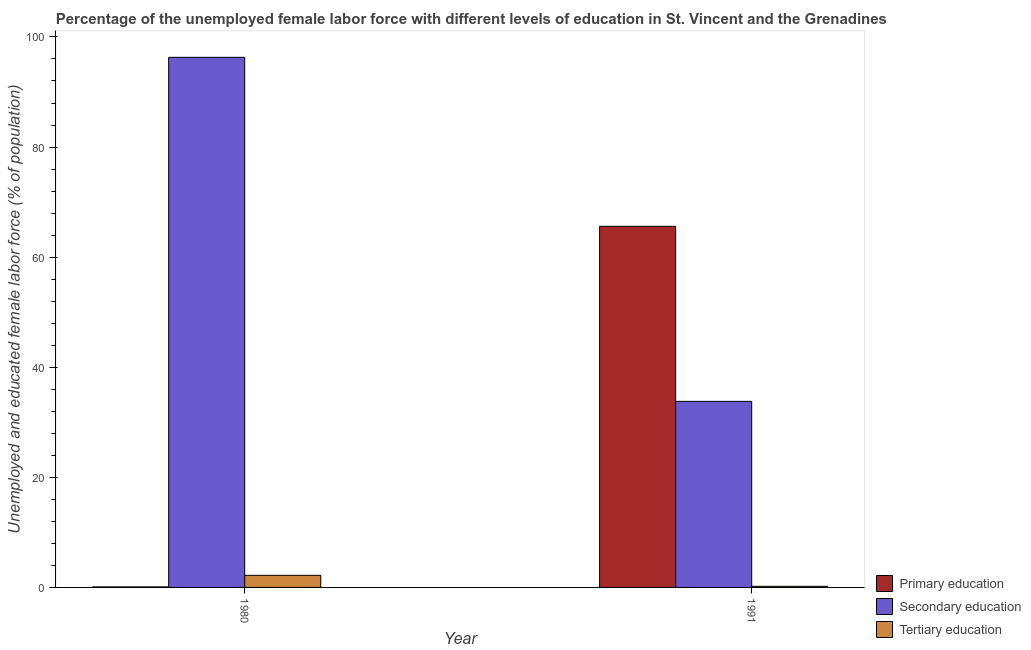How many different coloured bars are there?
Offer a terse response. 3. How many groups of bars are there?
Ensure brevity in your answer.  2. Are the number of bars per tick equal to the number of legend labels?
Your answer should be compact. Yes. Are the number of bars on each tick of the X-axis equal?
Offer a terse response. Yes. How many bars are there on the 1st tick from the right?
Make the answer very short. 3. What is the label of the 2nd group of bars from the left?
Your response must be concise. 1991. In how many cases, is the number of bars for a given year not equal to the number of legend labels?
Provide a succinct answer. 0. What is the percentage of female labor force who received primary education in 1980?
Make the answer very short. 0.1. Across all years, what is the maximum percentage of female labor force who received primary education?
Provide a short and direct response. 65.6. Across all years, what is the minimum percentage of female labor force who received secondary education?
Ensure brevity in your answer.  33.8. What is the total percentage of female labor force who received secondary education in the graph?
Offer a terse response. 130.1. What is the difference between the percentage of female labor force who received primary education in 1980 and that in 1991?
Ensure brevity in your answer.  -65.5. What is the difference between the percentage of female labor force who received primary education in 1980 and the percentage of female labor force who received secondary education in 1991?
Make the answer very short. -65.5. What is the average percentage of female labor force who received tertiary education per year?
Your answer should be compact. 1.2. In how many years, is the percentage of female labor force who received primary education greater than 40 %?
Provide a short and direct response. 1. What is the ratio of the percentage of female labor force who received tertiary education in 1980 to that in 1991?
Give a very brief answer. 11. In how many years, is the percentage of female labor force who received primary education greater than the average percentage of female labor force who received primary education taken over all years?
Keep it short and to the point. 1. What does the 2nd bar from the right in 1980 represents?
Make the answer very short. Secondary education. How many bars are there?
Keep it short and to the point. 6. Are all the bars in the graph horizontal?
Offer a terse response. No. How many years are there in the graph?
Provide a succinct answer. 2. What is the difference between two consecutive major ticks on the Y-axis?
Offer a very short reply. 20. Does the graph contain grids?
Offer a terse response. No. How many legend labels are there?
Give a very brief answer. 3. What is the title of the graph?
Offer a very short reply. Percentage of the unemployed female labor force with different levels of education in St. Vincent and the Grenadines. What is the label or title of the Y-axis?
Provide a short and direct response. Unemployed and educated female labor force (% of population). What is the Unemployed and educated female labor force (% of population) of Primary education in 1980?
Your answer should be compact. 0.1. What is the Unemployed and educated female labor force (% of population) in Secondary education in 1980?
Ensure brevity in your answer.  96.3. What is the Unemployed and educated female labor force (% of population) in Tertiary education in 1980?
Offer a terse response. 2.2. What is the Unemployed and educated female labor force (% of population) of Primary education in 1991?
Provide a succinct answer. 65.6. What is the Unemployed and educated female labor force (% of population) of Secondary education in 1991?
Ensure brevity in your answer.  33.8. What is the Unemployed and educated female labor force (% of population) of Tertiary education in 1991?
Give a very brief answer. 0.2. Across all years, what is the maximum Unemployed and educated female labor force (% of population) in Primary education?
Your answer should be compact. 65.6. Across all years, what is the maximum Unemployed and educated female labor force (% of population) in Secondary education?
Keep it short and to the point. 96.3. Across all years, what is the maximum Unemployed and educated female labor force (% of population) in Tertiary education?
Keep it short and to the point. 2.2. Across all years, what is the minimum Unemployed and educated female labor force (% of population) in Primary education?
Provide a succinct answer. 0.1. Across all years, what is the minimum Unemployed and educated female labor force (% of population) in Secondary education?
Your answer should be compact. 33.8. Across all years, what is the minimum Unemployed and educated female labor force (% of population) in Tertiary education?
Offer a very short reply. 0.2. What is the total Unemployed and educated female labor force (% of population) of Primary education in the graph?
Give a very brief answer. 65.7. What is the total Unemployed and educated female labor force (% of population) of Secondary education in the graph?
Provide a succinct answer. 130.1. What is the total Unemployed and educated female labor force (% of population) in Tertiary education in the graph?
Give a very brief answer. 2.4. What is the difference between the Unemployed and educated female labor force (% of population) in Primary education in 1980 and that in 1991?
Make the answer very short. -65.5. What is the difference between the Unemployed and educated female labor force (% of population) of Secondary education in 1980 and that in 1991?
Provide a succinct answer. 62.5. What is the difference between the Unemployed and educated female labor force (% of population) in Tertiary education in 1980 and that in 1991?
Your answer should be compact. 2. What is the difference between the Unemployed and educated female labor force (% of population) of Primary education in 1980 and the Unemployed and educated female labor force (% of population) of Secondary education in 1991?
Ensure brevity in your answer.  -33.7. What is the difference between the Unemployed and educated female labor force (% of population) of Primary education in 1980 and the Unemployed and educated female labor force (% of population) of Tertiary education in 1991?
Provide a succinct answer. -0.1. What is the difference between the Unemployed and educated female labor force (% of population) of Secondary education in 1980 and the Unemployed and educated female labor force (% of population) of Tertiary education in 1991?
Your response must be concise. 96.1. What is the average Unemployed and educated female labor force (% of population) of Primary education per year?
Make the answer very short. 32.85. What is the average Unemployed and educated female labor force (% of population) of Secondary education per year?
Your response must be concise. 65.05. In the year 1980, what is the difference between the Unemployed and educated female labor force (% of population) of Primary education and Unemployed and educated female labor force (% of population) of Secondary education?
Offer a terse response. -96.2. In the year 1980, what is the difference between the Unemployed and educated female labor force (% of population) in Secondary education and Unemployed and educated female labor force (% of population) in Tertiary education?
Your response must be concise. 94.1. In the year 1991, what is the difference between the Unemployed and educated female labor force (% of population) of Primary education and Unemployed and educated female labor force (% of population) of Secondary education?
Offer a very short reply. 31.8. In the year 1991, what is the difference between the Unemployed and educated female labor force (% of population) of Primary education and Unemployed and educated female labor force (% of population) of Tertiary education?
Make the answer very short. 65.4. In the year 1991, what is the difference between the Unemployed and educated female labor force (% of population) in Secondary education and Unemployed and educated female labor force (% of population) in Tertiary education?
Your answer should be very brief. 33.6. What is the ratio of the Unemployed and educated female labor force (% of population) in Primary education in 1980 to that in 1991?
Offer a very short reply. 0. What is the ratio of the Unemployed and educated female labor force (% of population) of Secondary education in 1980 to that in 1991?
Ensure brevity in your answer.  2.85. What is the difference between the highest and the second highest Unemployed and educated female labor force (% of population) in Primary education?
Ensure brevity in your answer.  65.5. What is the difference between the highest and the second highest Unemployed and educated female labor force (% of population) in Secondary education?
Your answer should be very brief. 62.5. What is the difference between the highest and the lowest Unemployed and educated female labor force (% of population) in Primary education?
Keep it short and to the point. 65.5. What is the difference between the highest and the lowest Unemployed and educated female labor force (% of population) in Secondary education?
Provide a succinct answer. 62.5. What is the difference between the highest and the lowest Unemployed and educated female labor force (% of population) of Tertiary education?
Offer a terse response. 2. 